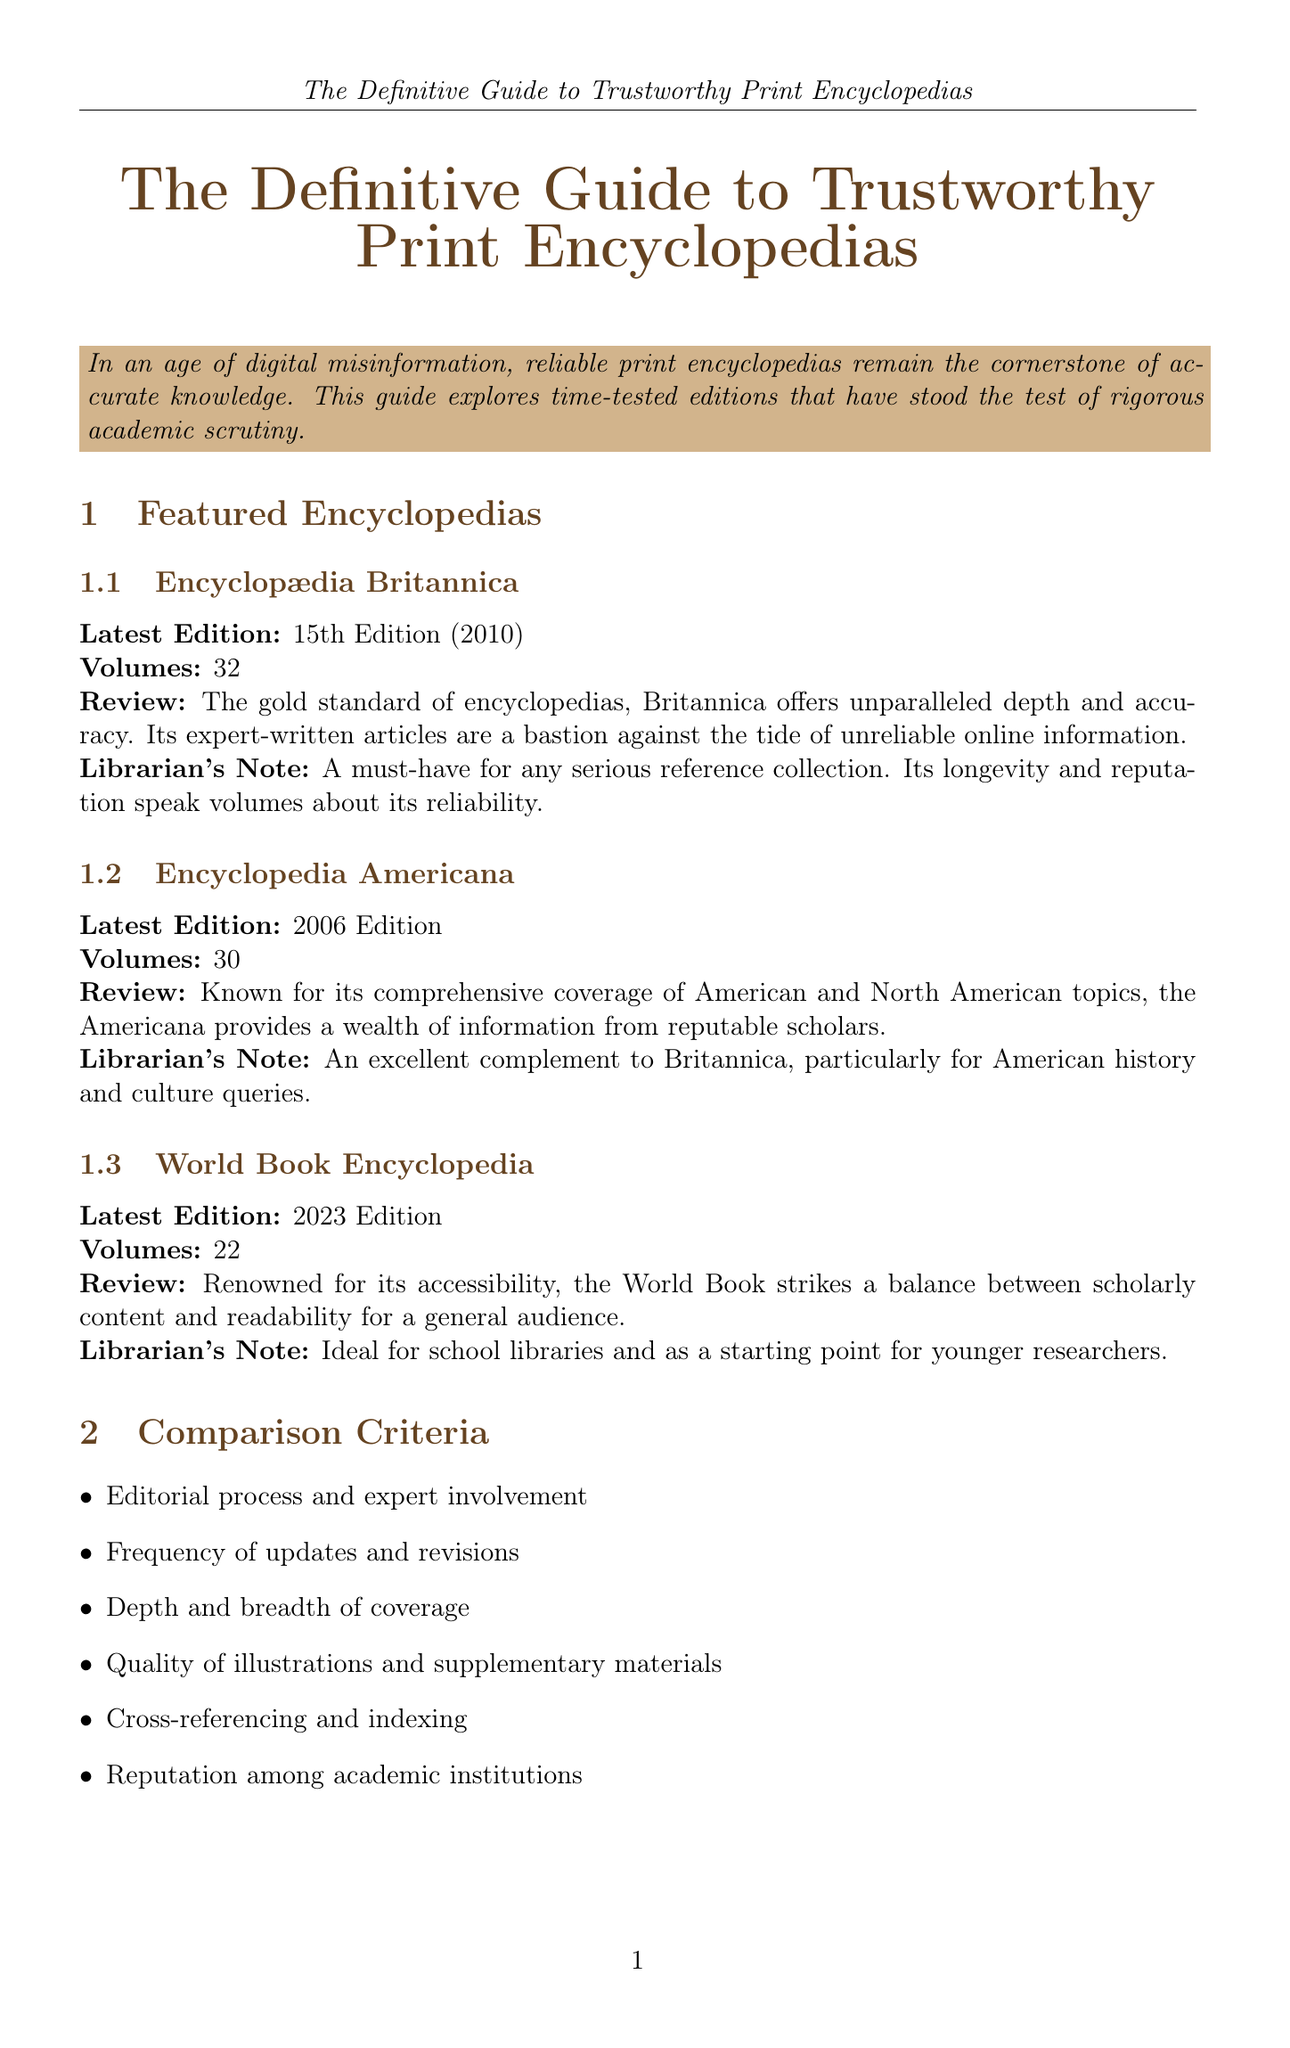What is the latest edition of Encyclopædia Britannica? The document states that the latest edition of Encyclopædia Britannica is the 15th Edition released in 2010.
Answer: 15th Edition (2010) How many volumes does the Encyclopedia Americana have? According to the document, the Encyclopedia Americana consists of 30 volumes.
Answer: 30 What year was the latest edition of the World Book Encyclopedia released? The document indicates that the latest edition of the World Book Encyclopedia was released in 2023.
Answer: 2023 Edition What is one of the benefits of print encyclopedias mentioned in the document? The document lists several benefits; one is that they provide vetted information by recognized experts.
Answer: Vetted information by recognized experts How does the depth of coverage of print encyclopedias compare to online sources according to the librarian's commentary? The librarian's commentary emphasizes that print encyclopedias offer authority and reliability unmatched by online sources.
Answer: Authority and reliability What is the recommended reference work edited by Margaret Drabble? The document specifies that the recommended work edited by Margaret Drabble is "The New Oxford Companion to Literature in English."
Answer: The New Oxford Companion to Literature in English What is a key comparison criterion for evaluating encyclopedias? The document mentions several criteria; one key criterion is the editorial process and expert involvement.
Answer: Editorial process and expert involvement For whom is the World Book Encyclopedia particularly ideal, according to the document? The document states that the World Book Encyclopedia is ideal for school libraries and younger researchers.
Answer: School libraries and younger researchers What does the conclusion state about the value of print encyclopedias? The conclusion asserts that the enduring value of print encyclopedias in providing reliable knowledge cannot be overstated.
Answer: Cannot be overstated 